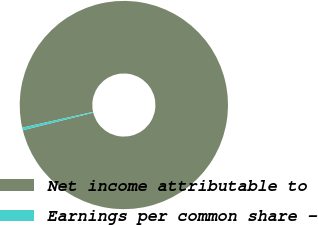Convert chart. <chart><loc_0><loc_0><loc_500><loc_500><pie_chart><fcel>Net income attributable to<fcel>Earnings per common share -<nl><fcel>99.59%<fcel>0.41%<nl></chart> 